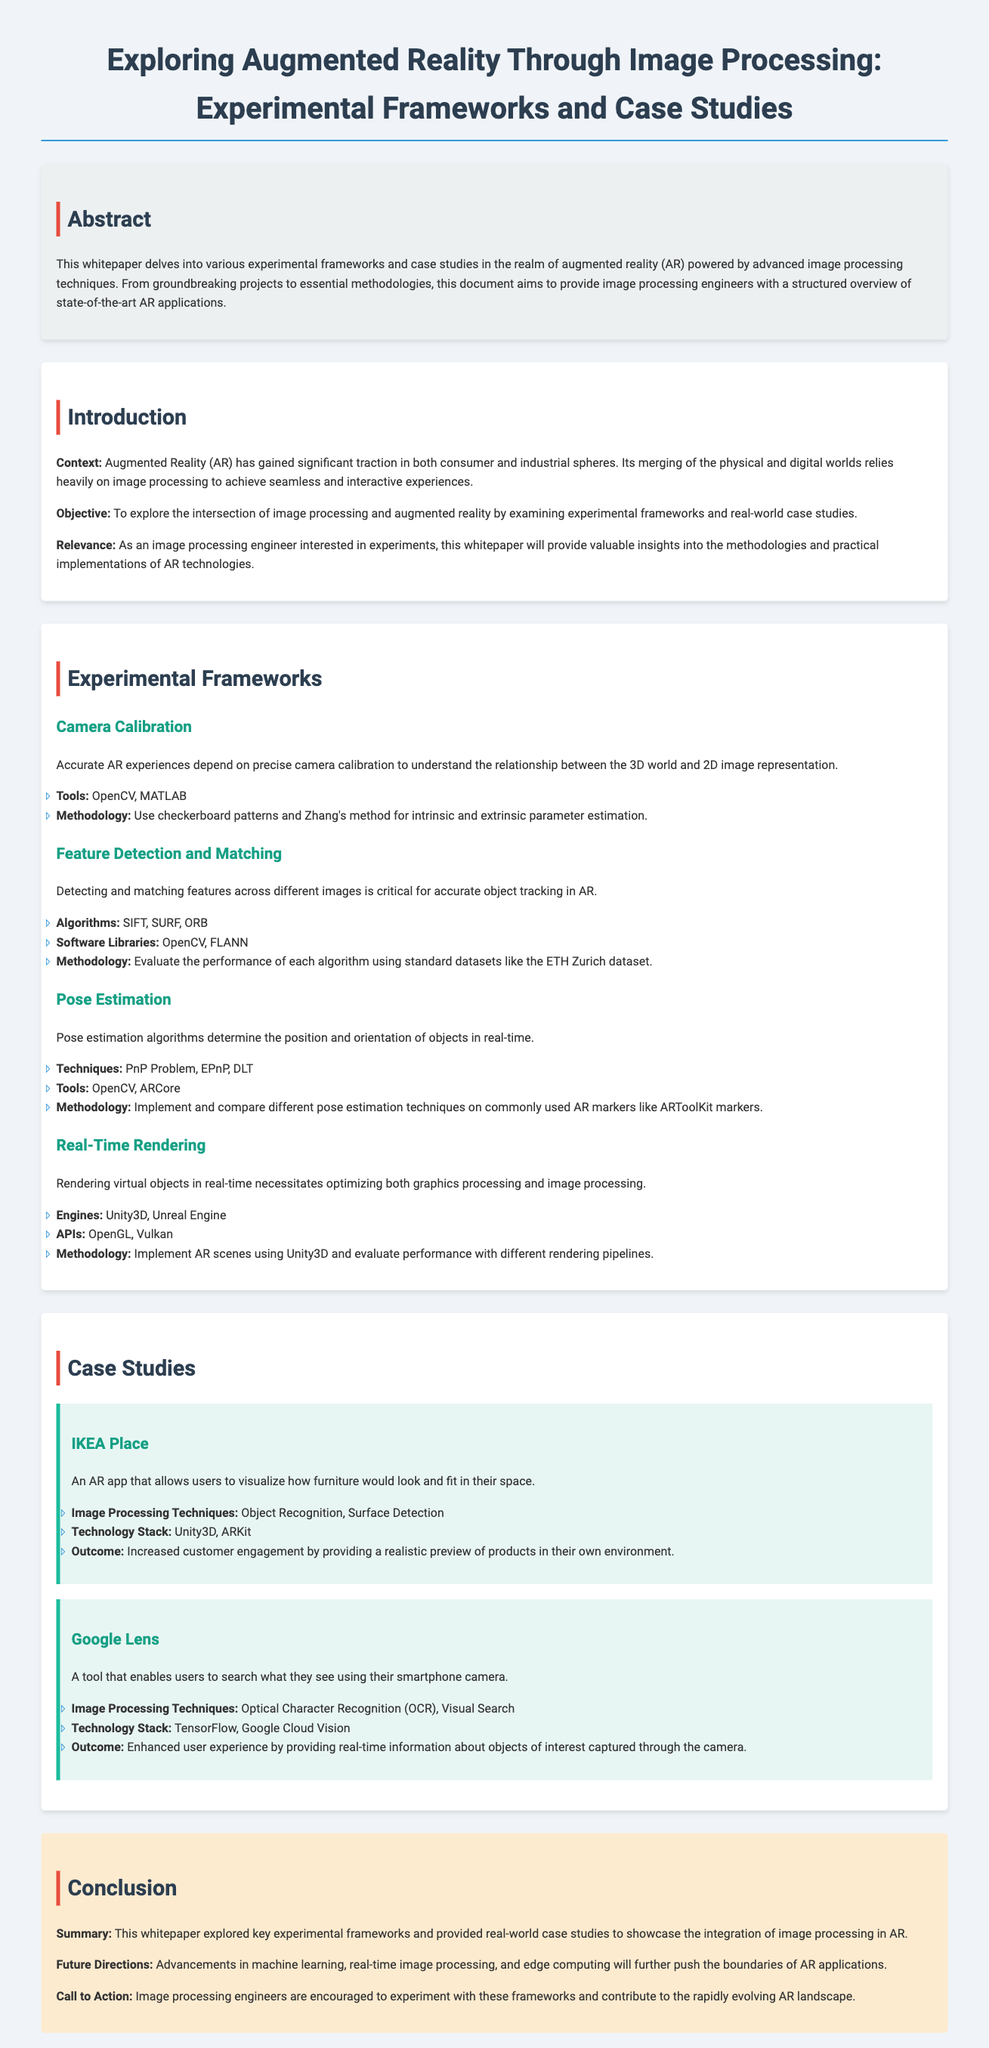What is the title of the whitepaper? The title is prominently displayed at the top of the document, introducing the main topic.
Answer: Exploring Augmented Reality Through Image Processing: Experimental Frameworks and Case Studies What methodology is suggested for camera calibration? The document details specific methodologies used in AR including the use of checkerboard patterns and Zhang's method.
Answer: Checkerboard patterns and Zhang's method Which software library is mentioned for feature detection? The document lists specific tools and libraries utilized in feature detection for AR applications, including OpenCV.
Answer: OpenCV What AR app is used as a case study for surface detection? The case studies presented in the document provide examples of AR applications highlighting specific techniques, including an AR app for furniture visualization.
Answer: IKEA Place What future direction does the conclusion suggest? The conclusion discusses advancements in technology that could influence the AR landscape, such as machine learning.
Answer: Machine learning How does Google Lens enhance user experience? The document illustrates how Google Lens uses image processing techniques to provide information in real-time, enhancing user interaction.
Answer: Real-time information What technology stack is used in the IKEA Place app? The document provides details on the technology stacks employed in various case studies, specifically mentioning the stack for the IKEA Place app.
Answer: Unity3D, ARKit Which image processing technique is used in Google Lens? The document specifies different techniques applied in case studies, including OCR for Google Lens.
Answer: Optical Character Recognition What is the main context of the document? The introduction outlines the broader topic and significance of the document regarding the integration of AR and image processing.
Answer: Significant traction in consumer and industrial spheres 